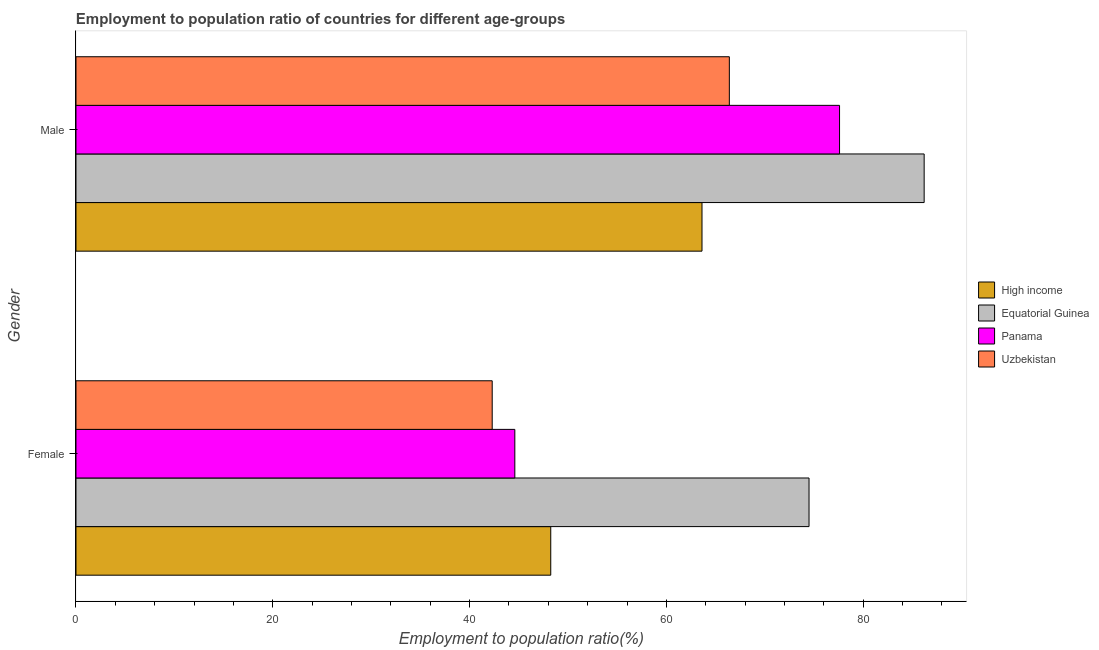How many groups of bars are there?
Your answer should be compact. 2. Are the number of bars per tick equal to the number of legend labels?
Your answer should be very brief. Yes. Are the number of bars on each tick of the Y-axis equal?
Offer a terse response. Yes. What is the label of the 2nd group of bars from the top?
Offer a terse response. Female. What is the employment to population ratio(female) in Equatorial Guinea?
Provide a short and direct response. 74.5. Across all countries, what is the maximum employment to population ratio(female)?
Offer a terse response. 74.5. Across all countries, what is the minimum employment to population ratio(female)?
Offer a terse response. 42.3. In which country was the employment to population ratio(male) maximum?
Provide a succinct answer. Equatorial Guinea. What is the total employment to population ratio(female) in the graph?
Provide a short and direct response. 209.65. What is the difference between the employment to population ratio(female) in Panama and that in High income?
Your answer should be compact. -3.65. What is the difference between the employment to population ratio(female) in Uzbekistan and the employment to population ratio(male) in Equatorial Guinea?
Your answer should be very brief. -43.9. What is the average employment to population ratio(male) per country?
Give a very brief answer. 73.46. What is the difference between the employment to population ratio(female) and employment to population ratio(male) in Equatorial Guinea?
Provide a short and direct response. -11.7. In how many countries, is the employment to population ratio(male) greater than 4 %?
Offer a very short reply. 4. What is the ratio of the employment to population ratio(male) in Equatorial Guinea to that in Uzbekistan?
Provide a short and direct response. 1.3. In how many countries, is the employment to population ratio(female) greater than the average employment to population ratio(female) taken over all countries?
Your response must be concise. 1. What does the 2nd bar from the top in Male represents?
Keep it short and to the point. Panama. What does the 1st bar from the bottom in Female represents?
Your answer should be very brief. High income. How many bars are there?
Provide a short and direct response. 8. How many countries are there in the graph?
Give a very brief answer. 4. Does the graph contain grids?
Ensure brevity in your answer.  No. How many legend labels are there?
Your response must be concise. 4. What is the title of the graph?
Offer a very short reply. Employment to population ratio of countries for different age-groups. What is the label or title of the Y-axis?
Your answer should be very brief. Gender. What is the Employment to population ratio(%) of High income in Female?
Your response must be concise. 48.25. What is the Employment to population ratio(%) in Equatorial Guinea in Female?
Keep it short and to the point. 74.5. What is the Employment to population ratio(%) of Panama in Female?
Your answer should be very brief. 44.6. What is the Employment to population ratio(%) in Uzbekistan in Female?
Keep it short and to the point. 42.3. What is the Employment to population ratio(%) in High income in Male?
Offer a terse response. 63.62. What is the Employment to population ratio(%) of Equatorial Guinea in Male?
Ensure brevity in your answer.  86.2. What is the Employment to population ratio(%) of Panama in Male?
Make the answer very short. 77.6. What is the Employment to population ratio(%) in Uzbekistan in Male?
Keep it short and to the point. 66.4. Across all Gender, what is the maximum Employment to population ratio(%) in High income?
Ensure brevity in your answer.  63.62. Across all Gender, what is the maximum Employment to population ratio(%) of Equatorial Guinea?
Give a very brief answer. 86.2. Across all Gender, what is the maximum Employment to population ratio(%) in Panama?
Your response must be concise. 77.6. Across all Gender, what is the maximum Employment to population ratio(%) of Uzbekistan?
Your answer should be compact. 66.4. Across all Gender, what is the minimum Employment to population ratio(%) of High income?
Offer a very short reply. 48.25. Across all Gender, what is the minimum Employment to population ratio(%) in Equatorial Guinea?
Provide a succinct answer. 74.5. Across all Gender, what is the minimum Employment to population ratio(%) of Panama?
Your answer should be very brief. 44.6. Across all Gender, what is the minimum Employment to population ratio(%) in Uzbekistan?
Your answer should be very brief. 42.3. What is the total Employment to population ratio(%) in High income in the graph?
Offer a very short reply. 111.87. What is the total Employment to population ratio(%) in Equatorial Guinea in the graph?
Your answer should be very brief. 160.7. What is the total Employment to population ratio(%) in Panama in the graph?
Your answer should be very brief. 122.2. What is the total Employment to population ratio(%) in Uzbekistan in the graph?
Give a very brief answer. 108.7. What is the difference between the Employment to population ratio(%) of High income in Female and that in Male?
Your response must be concise. -15.37. What is the difference between the Employment to population ratio(%) of Panama in Female and that in Male?
Your response must be concise. -33. What is the difference between the Employment to population ratio(%) in Uzbekistan in Female and that in Male?
Provide a succinct answer. -24.1. What is the difference between the Employment to population ratio(%) of High income in Female and the Employment to population ratio(%) of Equatorial Guinea in Male?
Give a very brief answer. -37.95. What is the difference between the Employment to population ratio(%) in High income in Female and the Employment to population ratio(%) in Panama in Male?
Keep it short and to the point. -29.35. What is the difference between the Employment to population ratio(%) in High income in Female and the Employment to population ratio(%) in Uzbekistan in Male?
Give a very brief answer. -18.15. What is the difference between the Employment to population ratio(%) of Panama in Female and the Employment to population ratio(%) of Uzbekistan in Male?
Keep it short and to the point. -21.8. What is the average Employment to population ratio(%) in High income per Gender?
Your answer should be compact. 55.94. What is the average Employment to population ratio(%) in Equatorial Guinea per Gender?
Provide a short and direct response. 80.35. What is the average Employment to population ratio(%) of Panama per Gender?
Make the answer very short. 61.1. What is the average Employment to population ratio(%) of Uzbekistan per Gender?
Ensure brevity in your answer.  54.35. What is the difference between the Employment to population ratio(%) in High income and Employment to population ratio(%) in Equatorial Guinea in Female?
Provide a short and direct response. -26.25. What is the difference between the Employment to population ratio(%) in High income and Employment to population ratio(%) in Panama in Female?
Offer a very short reply. 3.65. What is the difference between the Employment to population ratio(%) of High income and Employment to population ratio(%) of Uzbekistan in Female?
Offer a very short reply. 5.95. What is the difference between the Employment to population ratio(%) in Equatorial Guinea and Employment to population ratio(%) in Panama in Female?
Your response must be concise. 29.9. What is the difference between the Employment to population ratio(%) of Equatorial Guinea and Employment to population ratio(%) of Uzbekistan in Female?
Your answer should be compact. 32.2. What is the difference between the Employment to population ratio(%) in Panama and Employment to population ratio(%) in Uzbekistan in Female?
Ensure brevity in your answer.  2.3. What is the difference between the Employment to population ratio(%) in High income and Employment to population ratio(%) in Equatorial Guinea in Male?
Ensure brevity in your answer.  -22.58. What is the difference between the Employment to population ratio(%) in High income and Employment to population ratio(%) in Panama in Male?
Your answer should be very brief. -13.98. What is the difference between the Employment to population ratio(%) in High income and Employment to population ratio(%) in Uzbekistan in Male?
Your answer should be very brief. -2.78. What is the difference between the Employment to population ratio(%) in Equatorial Guinea and Employment to population ratio(%) in Uzbekistan in Male?
Give a very brief answer. 19.8. What is the difference between the Employment to population ratio(%) in Panama and Employment to population ratio(%) in Uzbekistan in Male?
Give a very brief answer. 11.2. What is the ratio of the Employment to population ratio(%) of High income in Female to that in Male?
Offer a very short reply. 0.76. What is the ratio of the Employment to population ratio(%) in Equatorial Guinea in Female to that in Male?
Make the answer very short. 0.86. What is the ratio of the Employment to population ratio(%) in Panama in Female to that in Male?
Offer a very short reply. 0.57. What is the ratio of the Employment to population ratio(%) in Uzbekistan in Female to that in Male?
Provide a succinct answer. 0.64. What is the difference between the highest and the second highest Employment to population ratio(%) of High income?
Ensure brevity in your answer.  15.37. What is the difference between the highest and the second highest Employment to population ratio(%) in Panama?
Provide a short and direct response. 33. What is the difference between the highest and the second highest Employment to population ratio(%) of Uzbekistan?
Your response must be concise. 24.1. What is the difference between the highest and the lowest Employment to population ratio(%) of High income?
Offer a terse response. 15.37. What is the difference between the highest and the lowest Employment to population ratio(%) of Uzbekistan?
Offer a terse response. 24.1. 